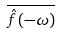<formula> <loc_0><loc_0><loc_500><loc_500>\overline { { { \hat { f } } ( - \omega ) } }</formula> 